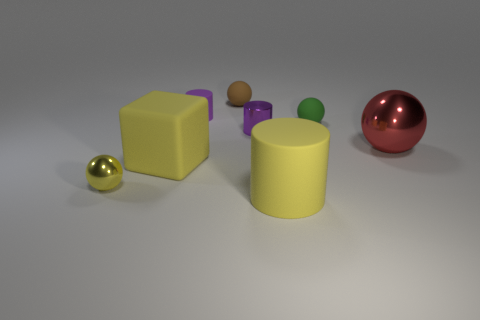Do the tiny rubber cylinder and the metal cylinder have the same color?
Provide a short and direct response. Yes. There is a cylinder behind the tiny purple metallic cylinder; does it have the same color as the tiny metallic cylinder?
Ensure brevity in your answer.  Yes. There is a shiny ball on the left side of the brown object; does it have the same color as the big object on the left side of the big rubber cylinder?
Your answer should be very brief. Yes. There is a tiny ball that is the same color as the big block; what material is it?
Keep it short and to the point. Metal. There is a large block that is the same material as the tiny brown object; what color is it?
Provide a short and direct response. Yellow. What is the material of the large thing that is the same shape as the tiny brown thing?
Make the answer very short. Metal. The small purple matte object has what shape?
Offer a terse response. Cylinder. The tiny thing that is both left of the brown rubber sphere and to the right of the tiny metal ball is made of what material?
Give a very brief answer. Rubber. There is a tiny green thing that is the same material as the block; what shape is it?
Give a very brief answer. Sphere. What is the size of the yellow object that is the same material as the large yellow cylinder?
Your answer should be very brief. Large. 